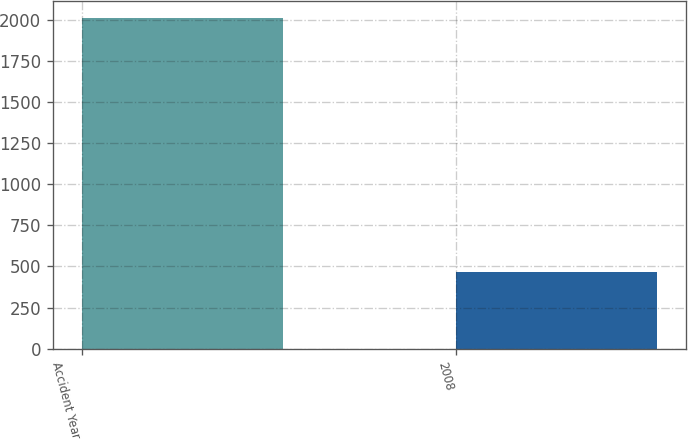Convert chart to OTSL. <chart><loc_0><loc_0><loc_500><loc_500><bar_chart><fcel>Accident Year<fcel>2008<nl><fcel>2013<fcel>464<nl></chart> 